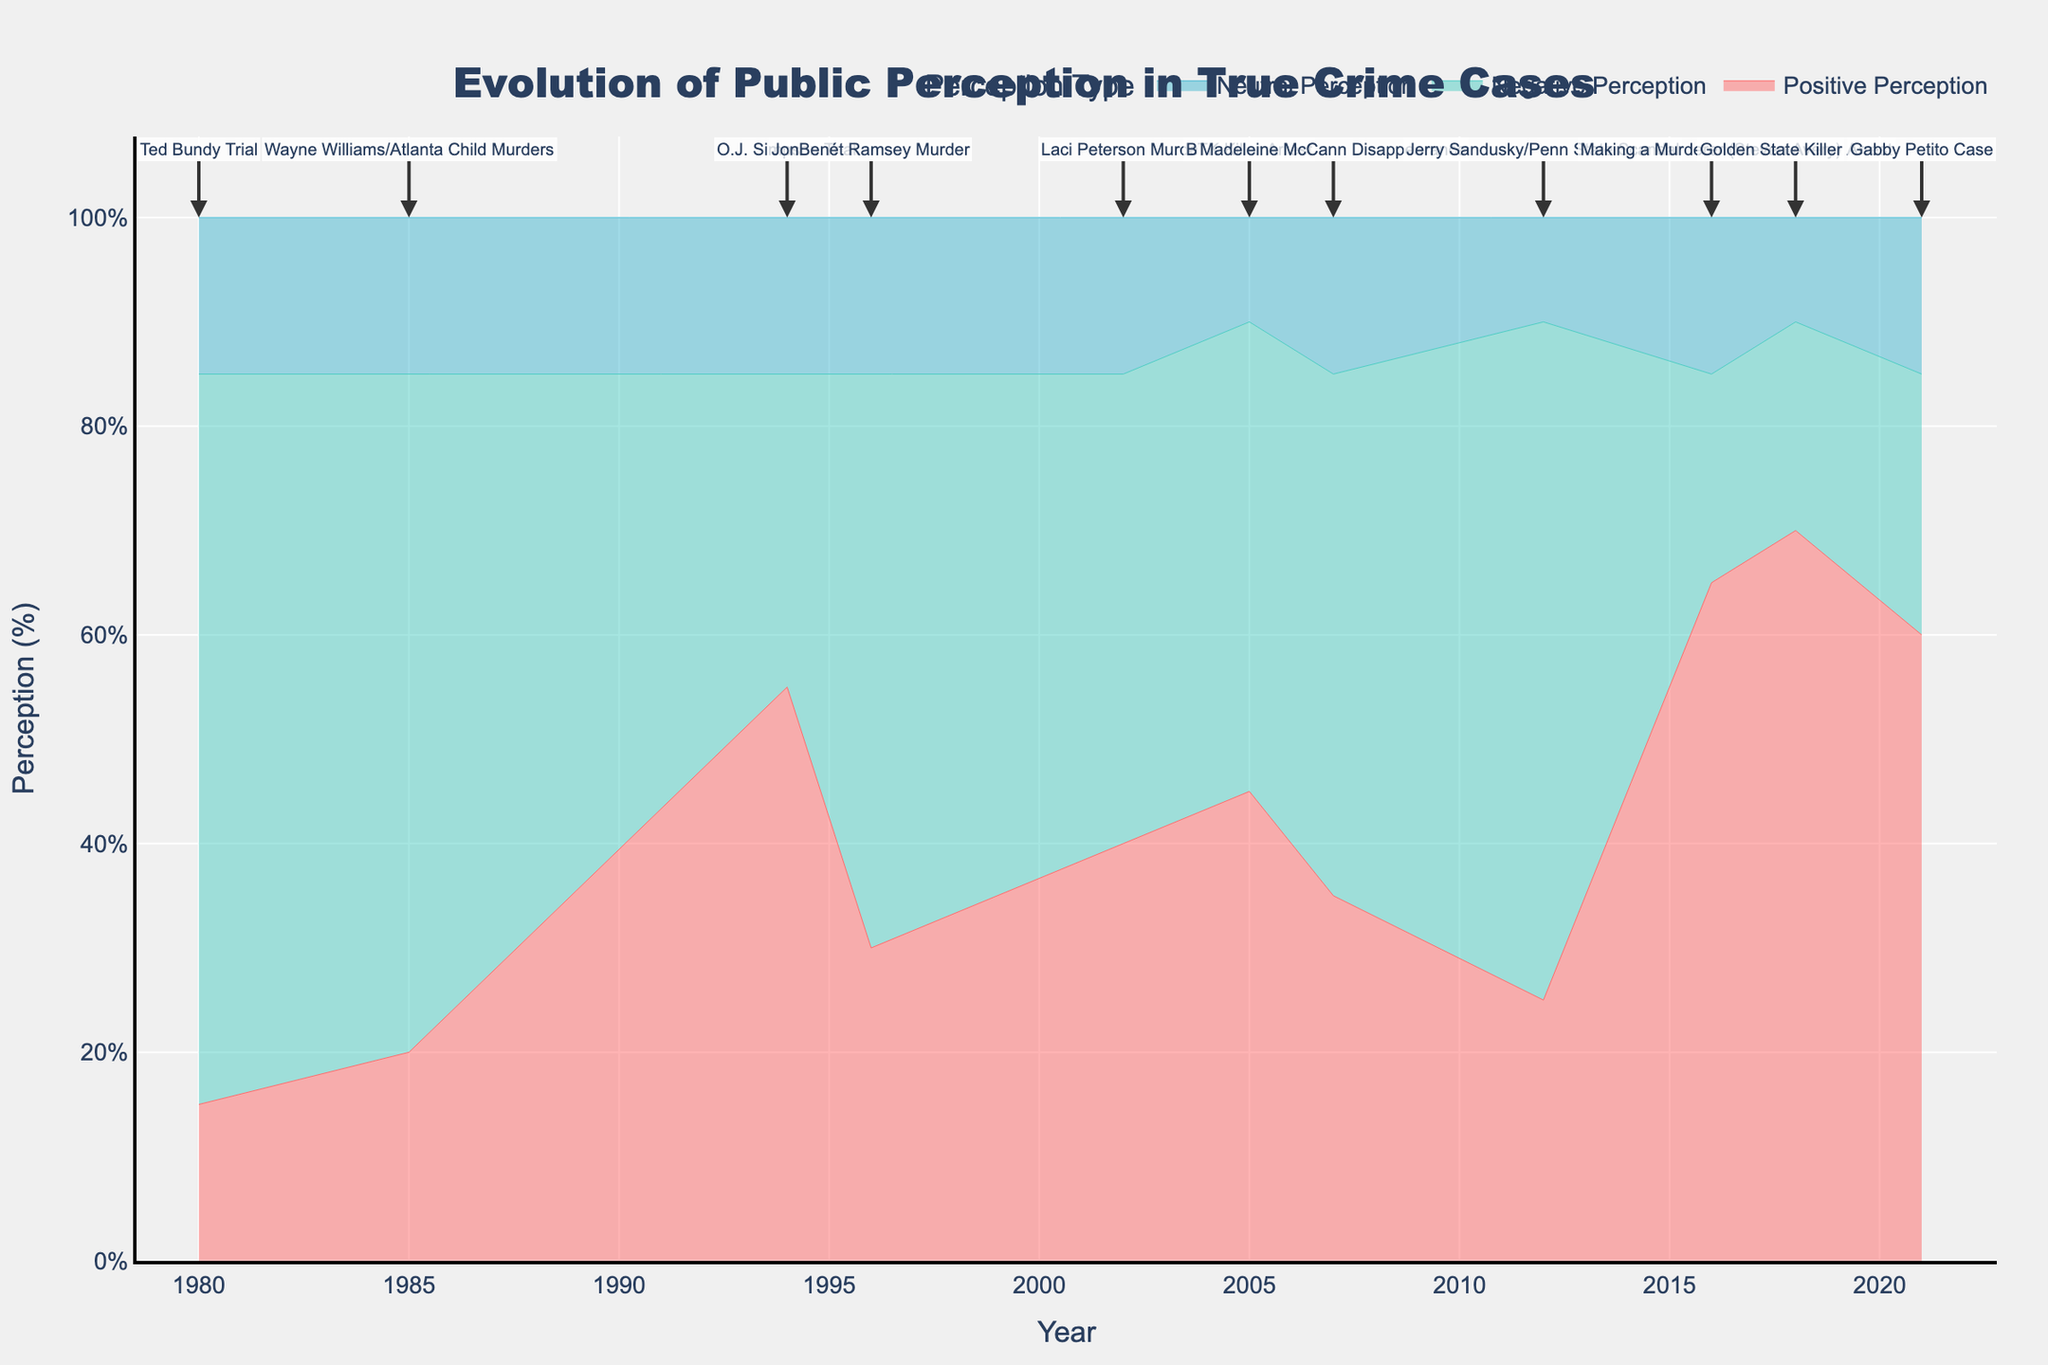What is the title of the figure? The title is typically located at the top of the chart and provides a brief description of the chart's content. Here, it states "Evolution of Public Perception in True Crime Cases."
Answer: Evolution of Public Perception in True Crime Cases Which case has the highest positive perception? To find this, we look for the point at which the 'Positive Perception' trace reaches its highest value. This is seen in the year 2018 during the "Golden State Killer Arrest" with 70%.
Answer: Golden State Killer Arrest What's the average positive perception for the "Ted Bundy Trial" and "Gabby Petito Case"? We sum the positive perceptions for the "Ted Bundy Trial" (15%) and "Gabby Petito Case" (60%), then divide by the number of cases: (15+60)/2.
Answer: 37.5% Compare the negative perception of the "O.J. Simpson Trial" with that of the "Steven Avery/Making a Murderer." Which one is higher and by how much? Negative perception for "O.J. Simpson Trial" is 30% and for "Steven Avery" is 20%. The difference is 30 - 20, so "O.J. Simpson Trial" is higher by 10%.
Answer: O.J. Simpson Trial, 10% During which case was the neutral perception the lowest? The 'Neutral Perception' trace where it dips down the most indicates the lowest neutral perception. This occurs during the "BTK Killer Arrest" with 10%.
Answer: BTK Killer Arrest How did the positive perception change from "JonBenét Ramsey Murder" to "Laci Peterson Murder"? Note the positive perception values for "JonBenét Ramsey Murder" (30%) and "Laci Peterson Murder" (40%). The change is 40 - 30.
Answer: Increased by 10% Which case had the most balanced views (equal positive, negative, and neutral perceptions)? By examining the traces, we find the "BTK Killer Arrest" shows equal positive and negative perceptions (45% each), and close to equal neutral perception (10%).
Answer: BTK Killer Arrest What is the overall trend in positive perceptions from 1980 to 2021? Observing the 'Positive Perception' trace over time, it shows a general increasing trend, starting from lower values (15% in 1980) to higher values (60-70% by 2021).
Answer: Increasing Which case has the highest difference between positive and negative perceptions? Calculate the differences for each case and identify the maximum difference. The highest difference is for "Golden State Killer Arrest" (70% positive - 20% negative = 50%).
Answer: Golden State Killer Arrest During which case in the 2000s did the neutral perception remain constant? Checking the 'Neutral Perception' trace for flat lines during 2000s cases, it remains at 15% for "Laci Peterson Murder," "Madeleine McCann Disappearance," and "Gabby Petito Case."
Answer: Laci Peterson Murder and Madeleine McCann Disappearance and Gabby Petito Case 